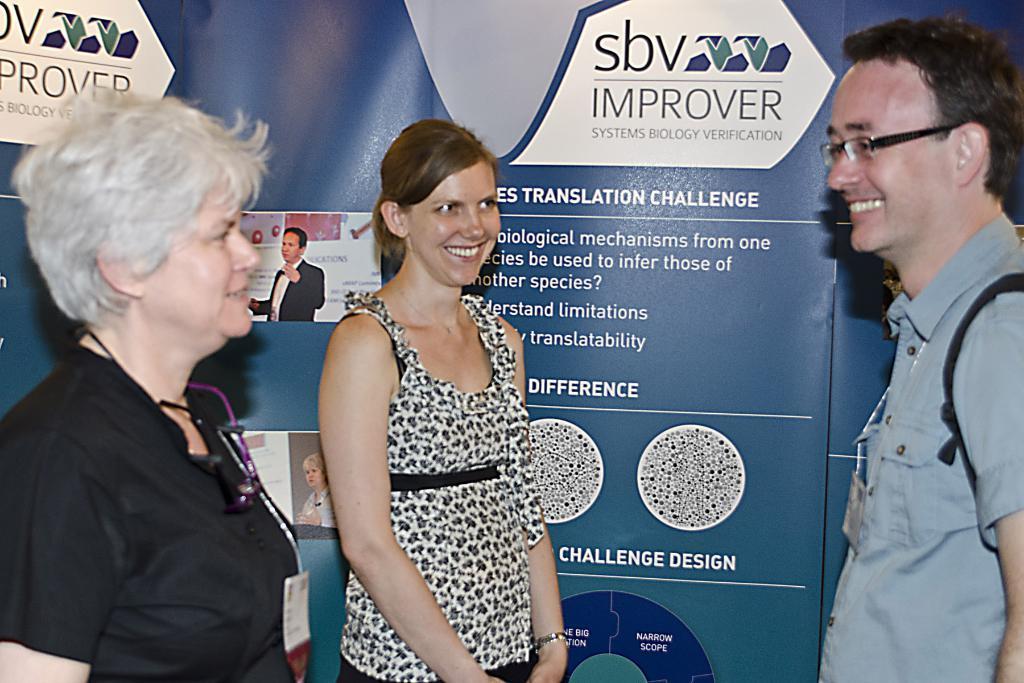Can you describe this image briefly? In this image I can see three persons standing. In front the person is wearing white and black color dress. In the background I can see the board in blue color and I can also see something written on the board. 